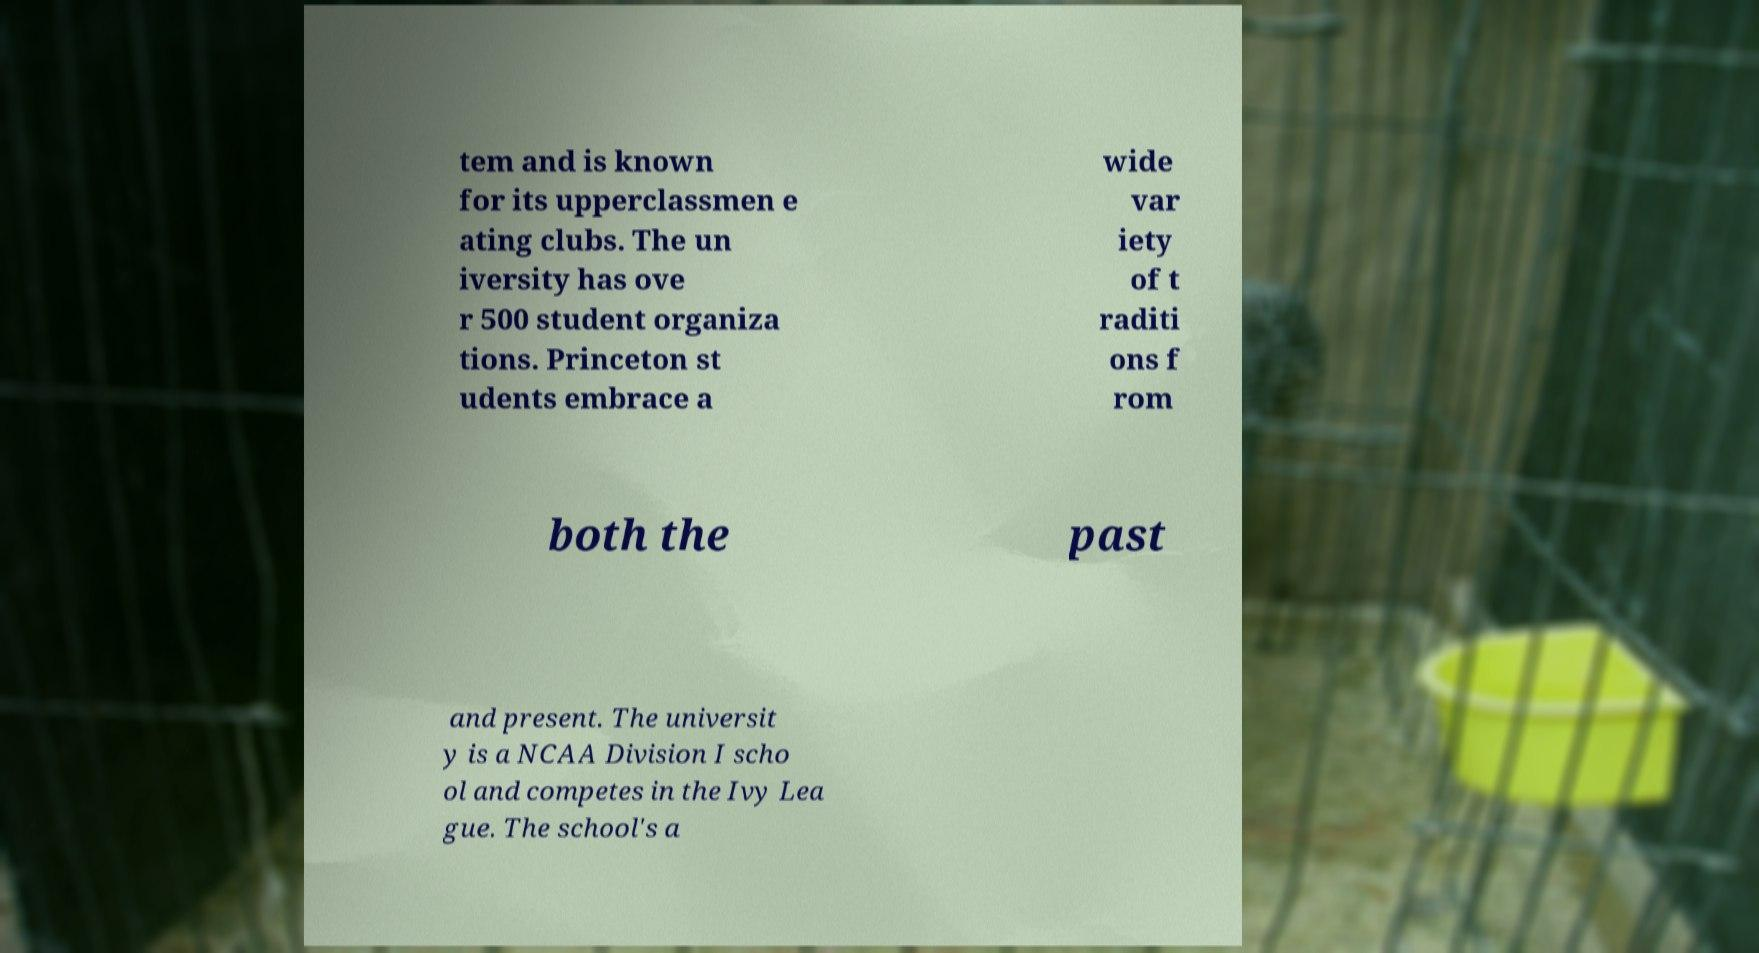For documentation purposes, I need the text within this image transcribed. Could you provide that? tem and is known for its upperclassmen e ating clubs. The un iversity has ove r 500 student organiza tions. Princeton st udents embrace a wide var iety of t raditi ons f rom both the past and present. The universit y is a NCAA Division I scho ol and competes in the Ivy Lea gue. The school's a 